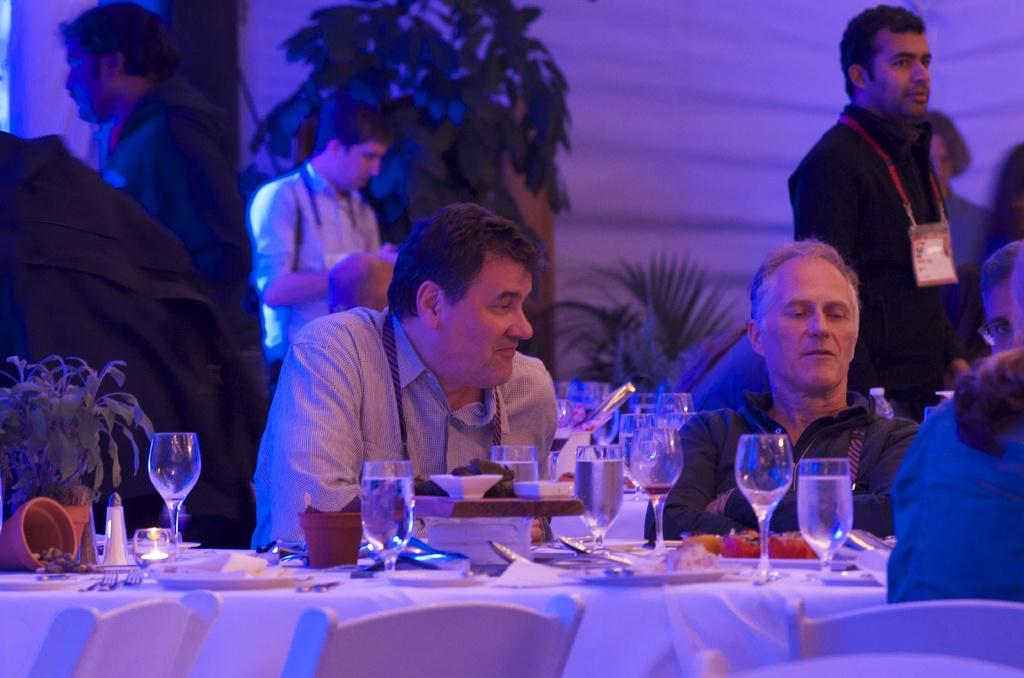What are the people in the image doing? The people in the image are sitting in chairs. What is in front of the sitting people? There is a table in front of the sitting people. What is on the table? The table has eatables and drinks on it. Are there any other people visible in the image? Yes, there are people standing in the background. How many ladybugs can be seen on the table in the image? There are no ladybugs present on the table in the image. What type of shop is visible in the background of the image? There is no shop visible in the image; it only shows people sitting and standing. 